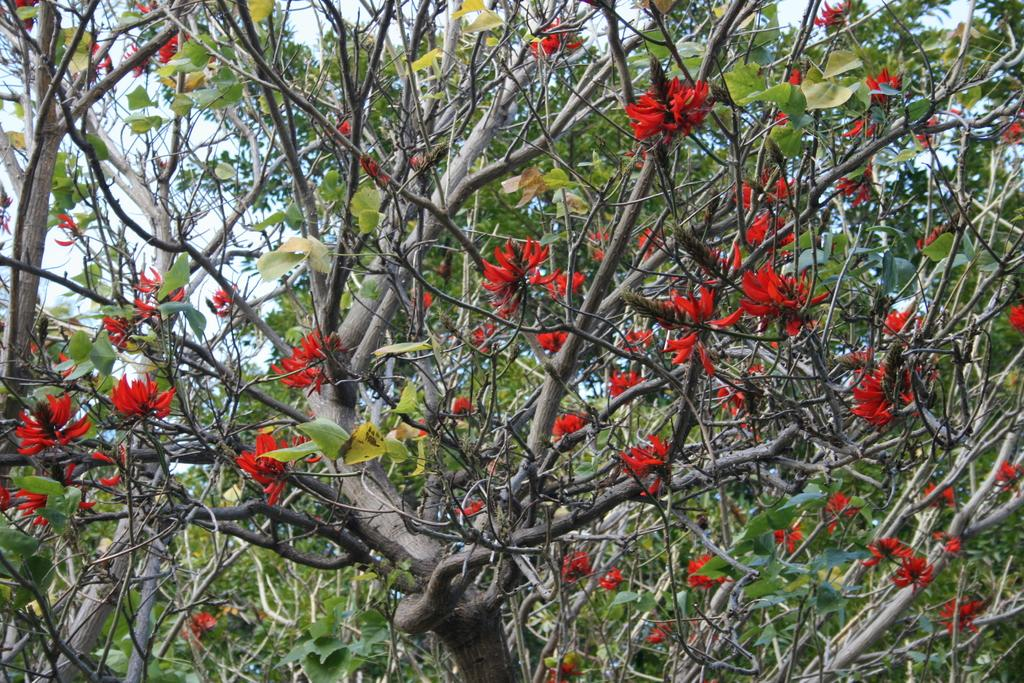What type of plant can be seen in the image? There is a tree in the image. What is the color of the sky in the image? The sky is white in the image. What is growing on the tree in the image? There are flowers on the tree. What color are the flowers on the tree? The flowers are red in color. What type of clock is hanging from the tree in the image? There is no clock present in the image; it only features a tree with red flowers and a white sky. 